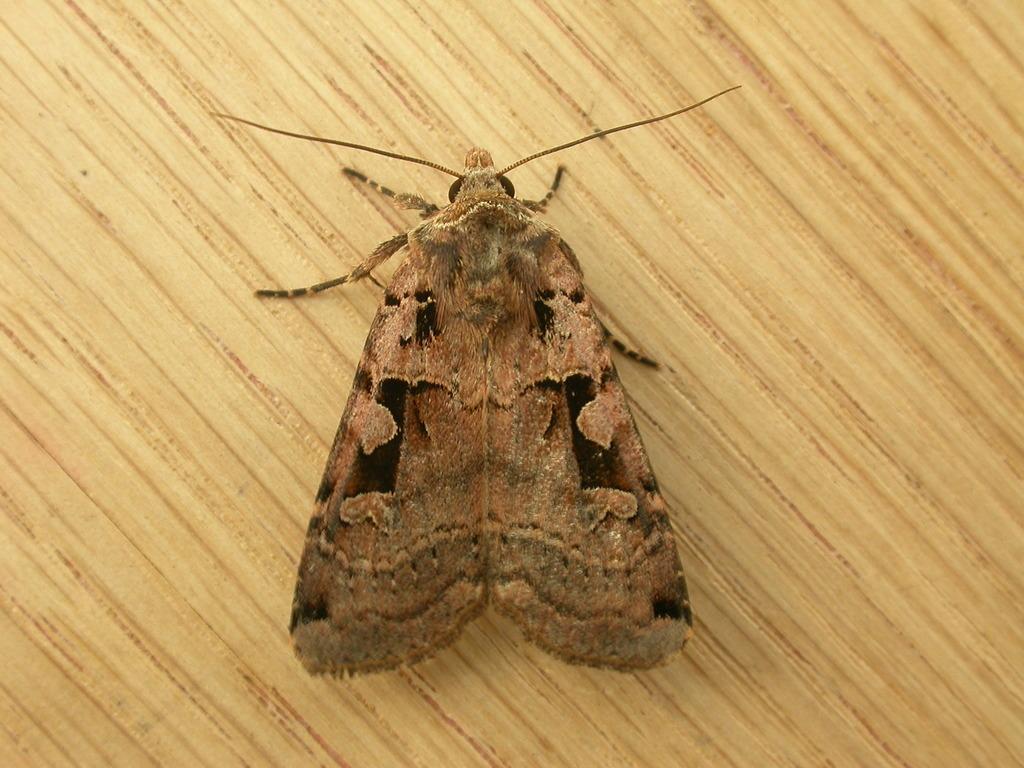Please provide a concise description of this image. In this image I can see an insect on a wooden surface. 